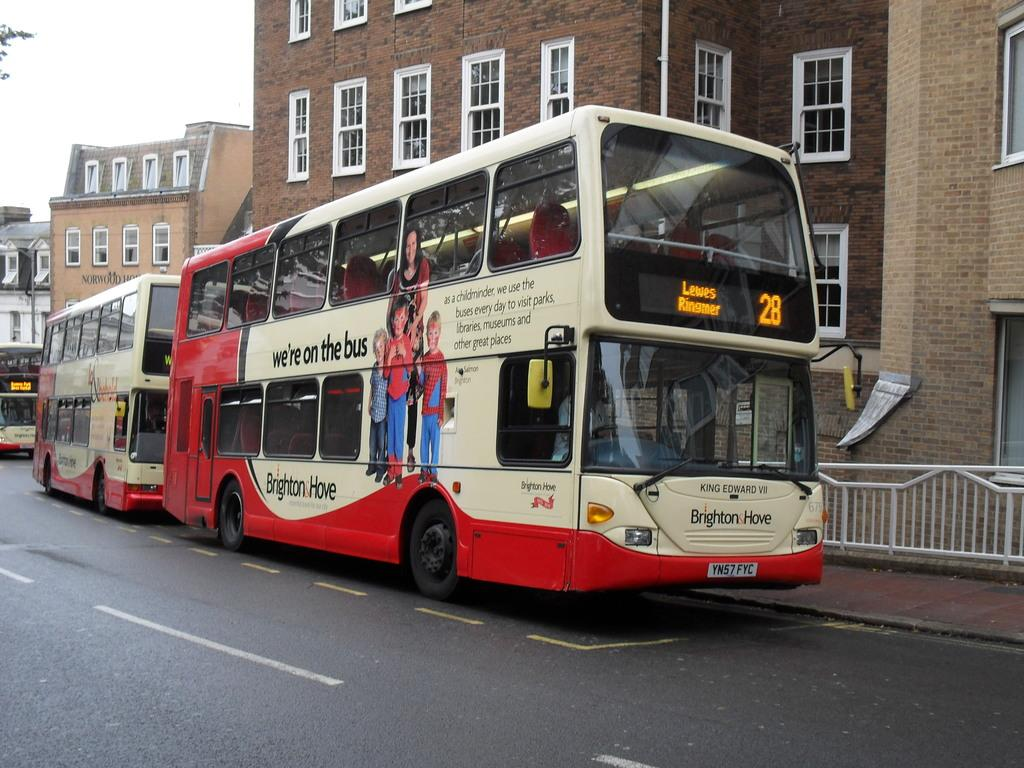What type of vehicles can be seen on the road in the image? There are buses on the road in the image. What is located on a pole in the image? There is a signboard on a pole in the image. What type of barrier is present in the image? There is a metal fence in the image. What type of structures are visible in the image? There are buildings with windows in the image. What is visible in the sky in the image? The sky is visible in the image and appears cloudy. What type of beds can be seen in the image? There are no beds present in the image. What type of cabbage is growing near the buses in the image? There is no cabbage present in the image; it is a scene of buses on a road with a signboard, metal fence, buildings, and a cloudy sky. 